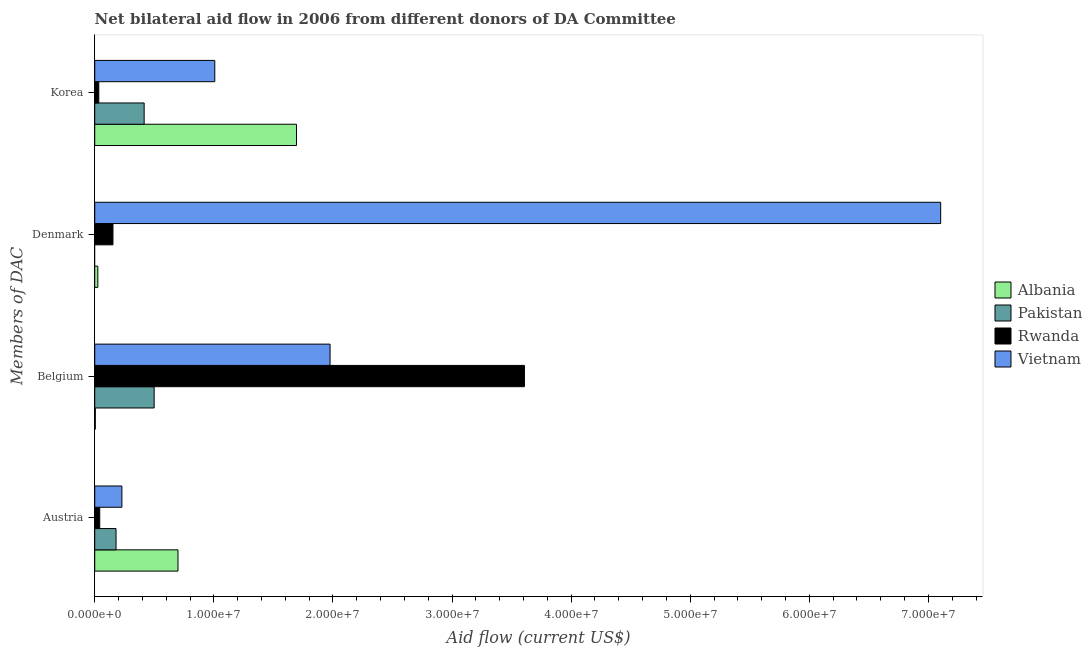How many different coloured bars are there?
Make the answer very short. 4. How many groups of bars are there?
Provide a short and direct response. 4. How many bars are there on the 2nd tick from the top?
Provide a succinct answer. 3. What is the label of the 4th group of bars from the top?
Your answer should be very brief. Austria. What is the amount of aid given by korea in Pakistan?
Your response must be concise. 4.15e+06. Across all countries, what is the maximum amount of aid given by belgium?
Your answer should be compact. 3.61e+07. Across all countries, what is the minimum amount of aid given by korea?
Give a very brief answer. 3.40e+05. In which country was the amount of aid given by austria maximum?
Your answer should be very brief. Albania. What is the total amount of aid given by austria in the graph?
Give a very brief answer. 1.15e+07. What is the difference between the amount of aid given by belgium in Rwanda and that in Vietnam?
Ensure brevity in your answer.  1.63e+07. What is the difference between the amount of aid given by denmark in Pakistan and the amount of aid given by belgium in Albania?
Give a very brief answer. -5.00e+04. What is the average amount of aid given by austria per country?
Provide a short and direct response. 2.87e+06. What is the difference between the amount of aid given by belgium and amount of aid given by denmark in Rwanda?
Keep it short and to the point. 3.46e+07. In how many countries, is the amount of aid given by belgium greater than 56000000 US$?
Keep it short and to the point. 0. What is the ratio of the amount of aid given by austria in Vietnam to that in Albania?
Your answer should be compact. 0.33. Is the difference between the amount of aid given by korea in Pakistan and Albania greater than the difference between the amount of aid given by belgium in Pakistan and Albania?
Provide a succinct answer. No. What is the difference between the highest and the second highest amount of aid given by belgium?
Ensure brevity in your answer.  1.63e+07. What is the difference between the highest and the lowest amount of aid given by austria?
Your answer should be compact. 6.57e+06. Is it the case that in every country, the sum of the amount of aid given by austria and amount of aid given by denmark is greater than the sum of amount of aid given by korea and amount of aid given by belgium?
Offer a terse response. No. Is it the case that in every country, the sum of the amount of aid given by austria and amount of aid given by belgium is greater than the amount of aid given by denmark?
Provide a succinct answer. No. Are all the bars in the graph horizontal?
Ensure brevity in your answer.  Yes. What is the difference between two consecutive major ticks on the X-axis?
Keep it short and to the point. 1.00e+07. How are the legend labels stacked?
Your answer should be very brief. Vertical. What is the title of the graph?
Ensure brevity in your answer.  Net bilateral aid flow in 2006 from different donors of DA Committee. Does "Faeroe Islands" appear as one of the legend labels in the graph?
Provide a succinct answer. No. What is the label or title of the Y-axis?
Provide a succinct answer. Members of DAC. What is the Aid flow (current US$) of Albania in Austria?
Provide a succinct answer. 6.99e+06. What is the Aid flow (current US$) of Pakistan in Austria?
Your answer should be very brief. 1.79e+06. What is the Aid flow (current US$) of Vietnam in Austria?
Offer a very short reply. 2.28e+06. What is the Aid flow (current US$) in Albania in Belgium?
Offer a terse response. 5.00e+04. What is the Aid flow (current US$) of Pakistan in Belgium?
Make the answer very short. 4.99e+06. What is the Aid flow (current US$) in Rwanda in Belgium?
Your answer should be compact. 3.61e+07. What is the Aid flow (current US$) in Vietnam in Belgium?
Offer a terse response. 1.98e+07. What is the Aid flow (current US$) in Albania in Denmark?
Ensure brevity in your answer.  2.60e+05. What is the Aid flow (current US$) of Pakistan in Denmark?
Your answer should be very brief. 0. What is the Aid flow (current US$) in Rwanda in Denmark?
Provide a succinct answer. 1.53e+06. What is the Aid flow (current US$) in Vietnam in Denmark?
Offer a terse response. 7.10e+07. What is the Aid flow (current US$) in Albania in Korea?
Keep it short and to the point. 1.69e+07. What is the Aid flow (current US$) of Pakistan in Korea?
Give a very brief answer. 4.15e+06. What is the Aid flow (current US$) in Rwanda in Korea?
Ensure brevity in your answer.  3.40e+05. What is the Aid flow (current US$) in Vietnam in Korea?
Provide a short and direct response. 1.01e+07. Across all Members of DAC, what is the maximum Aid flow (current US$) of Albania?
Provide a short and direct response. 1.69e+07. Across all Members of DAC, what is the maximum Aid flow (current US$) in Pakistan?
Your answer should be compact. 4.99e+06. Across all Members of DAC, what is the maximum Aid flow (current US$) in Rwanda?
Provide a short and direct response. 3.61e+07. Across all Members of DAC, what is the maximum Aid flow (current US$) of Vietnam?
Your answer should be compact. 7.10e+07. Across all Members of DAC, what is the minimum Aid flow (current US$) of Albania?
Ensure brevity in your answer.  5.00e+04. Across all Members of DAC, what is the minimum Aid flow (current US$) of Pakistan?
Make the answer very short. 0. Across all Members of DAC, what is the minimum Aid flow (current US$) in Rwanda?
Offer a very short reply. 3.40e+05. Across all Members of DAC, what is the minimum Aid flow (current US$) of Vietnam?
Keep it short and to the point. 2.28e+06. What is the total Aid flow (current US$) in Albania in the graph?
Your answer should be compact. 2.42e+07. What is the total Aid flow (current US$) in Pakistan in the graph?
Offer a very short reply. 1.09e+07. What is the total Aid flow (current US$) of Rwanda in the graph?
Your answer should be very brief. 3.84e+07. What is the total Aid flow (current US$) of Vietnam in the graph?
Your answer should be compact. 1.03e+08. What is the difference between the Aid flow (current US$) of Albania in Austria and that in Belgium?
Provide a succinct answer. 6.94e+06. What is the difference between the Aid flow (current US$) in Pakistan in Austria and that in Belgium?
Keep it short and to the point. -3.20e+06. What is the difference between the Aid flow (current US$) in Rwanda in Austria and that in Belgium?
Offer a terse response. -3.57e+07. What is the difference between the Aid flow (current US$) of Vietnam in Austria and that in Belgium?
Provide a succinct answer. -1.75e+07. What is the difference between the Aid flow (current US$) of Albania in Austria and that in Denmark?
Offer a very short reply. 6.73e+06. What is the difference between the Aid flow (current US$) of Rwanda in Austria and that in Denmark?
Your response must be concise. -1.11e+06. What is the difference between the Aid flow (current US$) in Vietnam in Austria and that in Denmark?
Your answer should be very brief. -6.88e+07. What is the difference between the Aid flow (current US$) in Albania in Austria and that in Korea?
Your response must be concise. -9.95e+06. What is the difference between the Aid flow (current US$) of Pakistan in Austria and that in Korea?
Your answer should be compact. -2.36e+06. What is the difference between the Aid flow (current US$) in Vietnam in Austria and that in Korea?
Provide a short and direct response. -7.80e+06. What is the difference between the Aid flow (current US$) of Albania in Belgium and that in Denmark?
Make the answer very short. -2.10e+05. What is the difference between the Aid flow (current US$) in Rwanda in Belgium and that in Denmark?
Ensure brevity in your answer.  3.46e+07. What is the difference between the Aid flow (current US$) in Vietnam in Belgium and that in Denmark?
Ensure brevity in your answer.  -5.13e+07. What is the difference between the Aid flow (current US$) of Albania in Belgium and that in Korea?
Your response must be concise. -1.69e+07. What is the difference between the Aid flow (current US$) of Pakistan in Belgium and that in Korea?
Provide a succinct answer. 8.40e+05. What is the difference between the Aid flow (current US$) in Rwanda in Belgium and that in Korea?
Make the answer very short. 3.57e+07. What is the difference between the Aid flow (current US$) in Vietnam in Belgium and that in Korea?
Your answer should be very brief. 9.68e+06. What is the difference between the Aid flow (current US$) in Albania in Denmark and that in Korea?
Your answer should be compact. -1.67e+07. What is the difference between the Aid flow (current US$) of Rwanda in Denmark and that in Korea?
Provide a short and direct response. 1.19e+06. What is the difference between the Aid flow (current US$) of Vietnam in Denmark and that in Korea?
Keep it short and to the point. 6.10e+07. What is the difference between the Aid flow (current US$) in Albania in Austria and the Aid flow (current US$) in Rwanda in Belgium?
Keep it short and to the point. -2.91e+07. What is the difference between the Aid flow (current US$) of Albania in Austria and the Aid flow (current US$) of Vietnam in Belgium?
Give a very brief answer. -1.28e+07. What is the difference between the Aid flow (current US$) of Pakistan in Austria and the Aid flow (current US$) of Rwanda in Belgium?
Your answer should be compact. -3.43e+07. What is the difference between the Aid flow (current US$) in Pakistan in Austria and the Aid flow (current US$) in Vietnam in Belgium?
Your answer should be compact. -1.80e+07. What is the difference between the Aid flow (current US$) in Rwanda in Austria and the Aid flow (current US$) in Vietnam in Belgium?
Give a very brief answer. -1.93e+07. What is the difference between the Aid flow (current US$) of Albania in Austria and the Aid flow (current US$) of Rwanda in Denmark?
Your answer should be very brief. 5.46e+06. What is the difference between the Aid flow (current US$) of Albania in Austria and the Aid flow (current US$) of Vietnam in Denmark?
Make the answer very short. -6.40e+07. What is the difference between the Aid flow (current US$) of Pakistan in Austria and the Aid flow (current US$) of Rwanda in Denmark?
Offer a terse response. 2.60e+05. What is the difference between the Aid flow (current US$) in Pakistan in Austria and the Aid flow (current US$) in Vietnam in Denmark?
Offer a very short reply. -6.92e+07. What is the difference between the Aid flow (current US$) of Rwanda in Austria and the Aid flow (current US$) of Vietnam in Denmark?
Give a very brief answer. -7.06e+07. What is the difference between the Aid flow (current US$) in Albania in Austria and the Aid flow (current US$) in Pakistan in Korea?
Your response must be concise. 2.84e+06. What is the difference between the Aid flow (current US$) of Albania in Austria and the Aid flow (current US$) of Rwanda in Korea?
Your answer should be very brief. 6.65e+06. What is the difference between the Aid flow (current US$) in Albania in Austria and the Aid flow (current US$) in Vietnam in Korea?
Your answer should be compact. -3.09e+06. What is the difference between the Aid flow (current US$) in Pakistan in Austria and the Aid flow (current US$) in Rwanda in Korea?
Give a very brief answer. 1.45e+06. What is the difference between the Aid flow (current US$) in Pakistan in Austria and the Aid flow (current US$) in Vietnam in Korea?
Keep it short and to the point. -8.29e+06. What is the difference between the Aid flow (current US$) of Rwanda in Austria and the Aid flow (current US$) of Vietnam in Korea?
Ensure brevity in your answer.  -9.66e+06. What is the difference between the Aid flow (current US$) in Albania in Belgium and the Aid flow (current US$) in Rwanda in Denmark?
Offer a terse response. -1.48e+06. What is the difference between the Aid flow (current US$) of Albania in Belgium and the Aid flow (current US$) of Vietnam in Denmark?
Provide a succinct answer. -7.10e+07. What is the difference between the Aid flow (current US$) of Pakistan in Belgium and the Aid flow (current US$) of Rwanda in Denmark?
Offer a very short reply. 3.46e+06. What is the difference between the Aid flow (current US$) of Pakistan in Belgium and the Aid flow (current US$) of Vietnam in Denmark?
Provide a short and direct response. -6.60e+07. What is the difference between the Aid flow (current US$) in Rwanda in Belgium and the Aid flow (current US$) in Vietnam in Denmark?
Provide a succinct answer. -3.50e+07. What is the difference between the Aid flow (current US$) in Albania in Belgium and the Aid flow (current US$) in Pakistan in Korea?
Ensure brevity in your answer.  -4.10e+06. What is the difference between the Aid flow (current US$) of Albania in Belgium and the Aid flow (current US$) of Rwanda in Korea?
Your answer should be compact. -2.90e+05. What is the difference between the Aid flow (current US$) of Albania in Belgium and the Aid flow (current US$) of Vietnam in Korea?
Give a very brief answer. -1.00e+07. What is the difference between the Aid flow (current US$) in Pakistan in Belgium and the Aid flow (current US$) in Rwanda in Korea?
Ensure brevity in your answer.  4.65e+06. What is the difference between the Aid flow (current US$) of Pakistan in Belgium and the Aid flow (current US$) of Vietnam in Korea?
Give a very brief answer. -5.09e+06. What is the difference between the Aid flow (current US$) of Rwanda in Belgium and the Aid flow (current US$) of Vietnam in Korea?
Your answer should be very brief. 2.60e+07. What is the difference between the Aid flow (current US$) of Albania in Denmark and the Aid flow (current US$) of Pakistan in Korea?
Provide a short and direct response. -3.89e+06. What is the difference between the Aid flow (current US$) in Albania in Denmark and the Aid flow (current US$) in Rwanda in Korea?
Ensure brevity in your answer.  -8.00e+04. What is the difference between the Aid flow (current US$) in Albania in Denmark and the Aid flow (current US$) in Vietnam in Korea?
Make the answer very short. -9.82e+06. What is the difference between the Aid flow (current US$) of Rwanda in Denmark and the Aid flow (current US$) of Vietnam in Korea?
Keep it short and to the point. -8.55e+06. What is the average Aid flow (current US$) in Albania per Members of DAC?
Offer a terse response. 6.06e+06. What is the average Aid flow (current US$) in Pakistan per Members of DAC?
Offer a very short reply. 2.73e+06. What is the average Aid flow (current US$) of Rwanda per Members of DAC?
Provide a short and direct response. 9.59e+06. What is the average Aid flow (current US$) of Vietnam per Members of DAC?
Provide a short and direct response. 2.58e+07. What is the difference between the Aid flow (current US$) of Albania and Aid flow (current US$) of Pakistan in Austria?
Offer a terse response. 5.20e+06. What is the difference between the Aid flow (current US$) of Albania and Aid flow (current US$) of Rwanda in Austria?
Provide a short and direct response. 6.57e+06. What is the difference between the Aid flow (current US$) in Albania and Aid flow (current US$) in Vietnam in Austria?
Your answer should be very brief. 4.71e+06. What is the difference between the Aid flow (current US$) in Pakistan and Aid flow (current US$) in Rwanda in Austria?
Offer a terse response. 1.37e+06. What is the difference between the Aid flow (current US$) in Pakistan and Aid flow (current US$) in Vietnam in Austria?
Make the answer very short. -4.90e+05. What is the difference between the Aid flow (current US$) of Rwanda and Aid flow (current US$) of Vietnam in Austria?
Ensure brevity in your answer.  -1.86e+06. What is the difference between the Aid flow (current US$) of Albania and Aid flow (current US$) of Pakistan in Belgium?
Offer a very short reply. -4.94e+06. What is the difference between the Aid flow (current US$) in Albania and Aid flow (current US$) in Rwanda in Belgium?
Your answer should be compact. -3.60e+07. What is the difference between the Aid flow (current US$) of Albania and Aid flow (current US$) of Vietnam in Belgium?
Provide a short and direct response. -1.97e+07. What is the difference between the Aid flow (current US$) in Pakistan and Aid flow (current US$) in Rwanda in Belgium?
Keep it short and to the point. -3.11e+07. What is the difference between the Aid flow (current US$) of Pakistan and Aid flow (current US$) of Vietnam in Belgium?
Your answer should be very brief. -1.48e+07. What is the difference between the Aid flow (current US$) in Rwanda and Aid flow (current US$) in Vietnam in Belgium?
Give a very brief answer. 1.63e+07. What is the difference between the Aid flow (current US$) of Albania and Aid flow (current US$) of Rwanda in Denmark?
Your answer should be compact. -1.27e+06. What is the difference between the Aid flow (current US$) in Albania and Aid flow (current US$) in Vietnam in Denmark?
Give a very brief answer. -7.08e+07. What is the difference between the Aid flow (current US$) of Rwanda and Aid flow (current US$) of Vietnam in Denmark?
Offer a very short reply. -6.95e+07. What is the difference between the Aid flow (current US$) in Albania and Aid flow (current US$) in Pakistan in Korea?
Make the answer very short. 1.28e+07. What is the difference between the Aid flow (current US$) of Albania and Aid flow (current US$) of Rwanda in Korea?
Your answer should be very brief. 1.66e+07. What is the difference between the Aid flow (current US$) of Albania and Aid flow (current US$) of Vietnam in Korea?
Provide a succinct answer. 6.86e+06. What is the difference between the Aid flow (current US$) in Pakistan and Aid flow (current US$) in Rwanda in Korea?
Your answer should be compact. 3.81e+06. What is the difference between the Aid flow (current US$) of Pakistan and Aid flow (current US$) of Vietnam in Korea?
Provide a short and direct response. -5.93e+06. What is the difference between the Aid flow (current US$) of Rwanda and Aid flow (current US$) of Vietnam in Korea?
Offer a very short reply. -9.74e+06. What is the ratio of the Aid flow (current US$) in Albania in Austria to that in Belgium?
Your answer should be very brief. 139.8. What is the ratio of the Aid flow (current US$) in Pakistan in Austria to that in Belgium?
Offer a terse response. 0.36. What is the ratio of the Aid flow (current US$) of Rwanda in Austria to that in Belgium?
Provide a succinct answer. 0.01. What is the ratio of the Aid flow (current US$) in Vietnam in Austria to that in Belgium?
Your answer should be very brief. 0.12. What is the ratio of the Aid flow (current US$) in Albania in Austria to that in Denmark?
Your answer should be very brief. 26.88. What is the ratio of the Aid flow (current US$) in Rwanda in Austria to that in Denmark?
Provide a short and direct response. 0.27. What is the ratio of the Aid flow (current US$) in Vietnam in Austria to that in Denmark?
Your answer should be very brief. 0.03. What is the ratio of the Aid flow (current US$) of Albania in Austria to that in Korea?
Your response must be concise. 0.41. What is the ratio of the Aid flow (current US$) of Pakistan in Austria to that in Korea?
Provide a succinct answer. 0.43. What is the ratio of the Aid flow (current US$) in Rwanda in Austria to that in Korea?
Your answer should be compact. 1.24. What is the ratio of the Aid flow (current US$) of Vietnam in Austria to that in Korea?
Make the answer very short. 0.23. What is the ratio of the Aid flow (current US$) in Albania in Belgium to that in Denmark?
Your answer should be very brief. 0.19. What is the ratio of the Aid flow (current US$) of Rwanda in Belgium to that in Denmark?
Offer a terse response. 23.58. What is the ratio of the Aid flow (current US$) in Vietnam in Belgium to that in Denmark?
Offer a terse response. 0.28. What is the ratio of the Aid flow (current US$) of Albania in Belgium to that in Korea?
Ensure brevity in your answer.  0. What is the ratio of the Aid flow (current US$) of Pakistan in Belgium to that in Korea?
Provide a short and direct response. 1.2. What is the ratio of the Aid flow (current US$) of Rwanda in Belgium to that in Korea?
Offer a terse response. 106.12. What is the ratio of the Aid flow (current US$) in Vietnam in Belgium to that in Korea?
Your response must be concise. 1.96. What is the ratio of the Aid flow (current US$) in Albania in Denmark to that in Korea?
Provide a short and direct response. 0.02. What is the ratio of the Aid flow (current US$) of Rwanda in Denmark to that in Korea?
Offer a very short reply. 4.5. What is the ratio of the Aid flow (current US$) in Vietnam in Denmark to that in Korea?
Your answer should be very brief. 7.05. What is the difference between the highest and the second highest Aid flow (current US$) in Albania?
Your answer should be compact. 9.95e+06. What is the difference between the highest and the second highest Aid flow (current US$) in Pakistan?
Give a very brief answer. 8.40e+05. What is the difference between the highest and the second highest Aid flow (current US$) in Rwanda?
Ensure brevity in your answer.  3.46e+07. What is the difference between the highest and the second highest Aid flow (current US$) of Vietnam?
Offer a terse response. 5.13e+07. What is the difference between the highest and the lowest Aid flow (current US$) in Albania?
Your response must be concise. 1.69e+07. What is the difference between the highest and the lowest Aid flow (current US$) in Pakistan?
Your response must be concise. 4.99e+06. What is the difference between the highest and the lowest Aid flow (current US$) of Rwanda?
Provide a short and direct response. 3.57e+07. What is the difference between the highest and the lowest Aid flow (current US$) of Vietnam?
Your answer should be compact. 6.88e+07. 